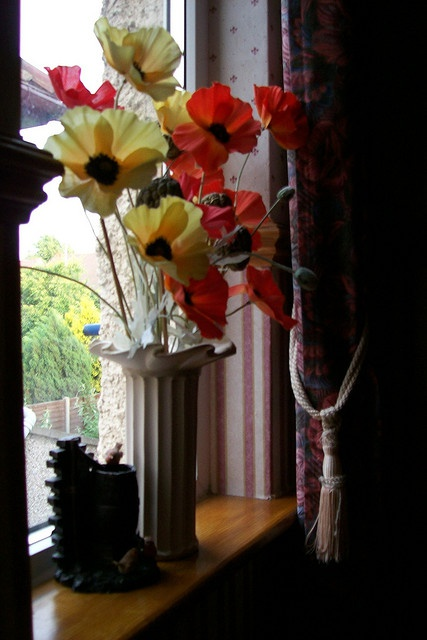Describe the objects in this image and their specific colors. I can see potted plant in black, maroon, darkgray, and olive tones and vase in black, gray, and darkgray tones in this image. 